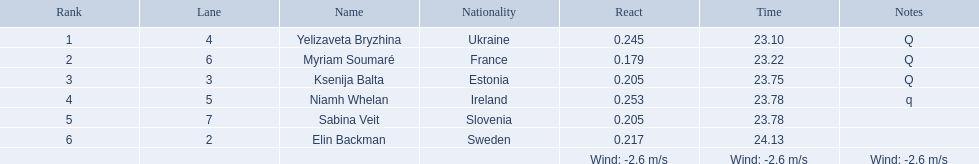Parse the table in full. {'header': ['Rank', 'Lane', 'Name', 'Nationality', 'React', 'Time', 'Notes'], 'rows': [['1', '4', 'Yelizaveta Bryzhina', 'Ukraine', '0.245', '23.10', 'Q'], ['2', '6', 'Myriam Soumaré', 'France', '0.179', '23.22', 'Q'], ['3', '3', 'Ksenija Balta', 'Estonia', '0.205', '23.75', 'Q'], ['4', '5', 'Niamh Whelan', 'Ireland', '0.253', '23.78', 'q'], ['5', '7', 'Sabina Veit', 'Slovenia', '0.205', '23.78', ''], ['6', '2', 'Elin Backman', 'Sweden', '0.217', '24.13', ''], ['', '', '', '', 'Wind: -2.6\xa0m/s', 'Wind: -2.6\xa0m/s', 'Wind: -2.6\xa0m/s']]} Are there any sequentially ordered lanes? No. 